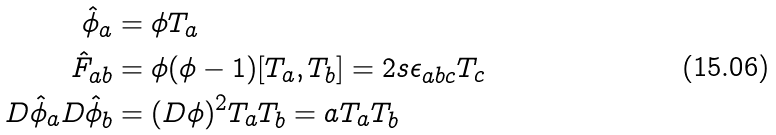<formula> <loc_0><loc_0><loc_500><loc_500>\hat { \phi } _ { a } & = \phi T _ { a } \\ \hat { F } _ { a b } & = \phi ( \phi - 1 ) [ T _ { a } , T _ { b } ] = 2 s \epsilon _ { a b c } T _ { c } \\ D \hat { \phi } _ { a } D \hat { \phi } _ { b } & = ( D \phi ) ^ { 2 } T _ { a } T _ { b } = a T _ { a } T _ { b }</formula> 